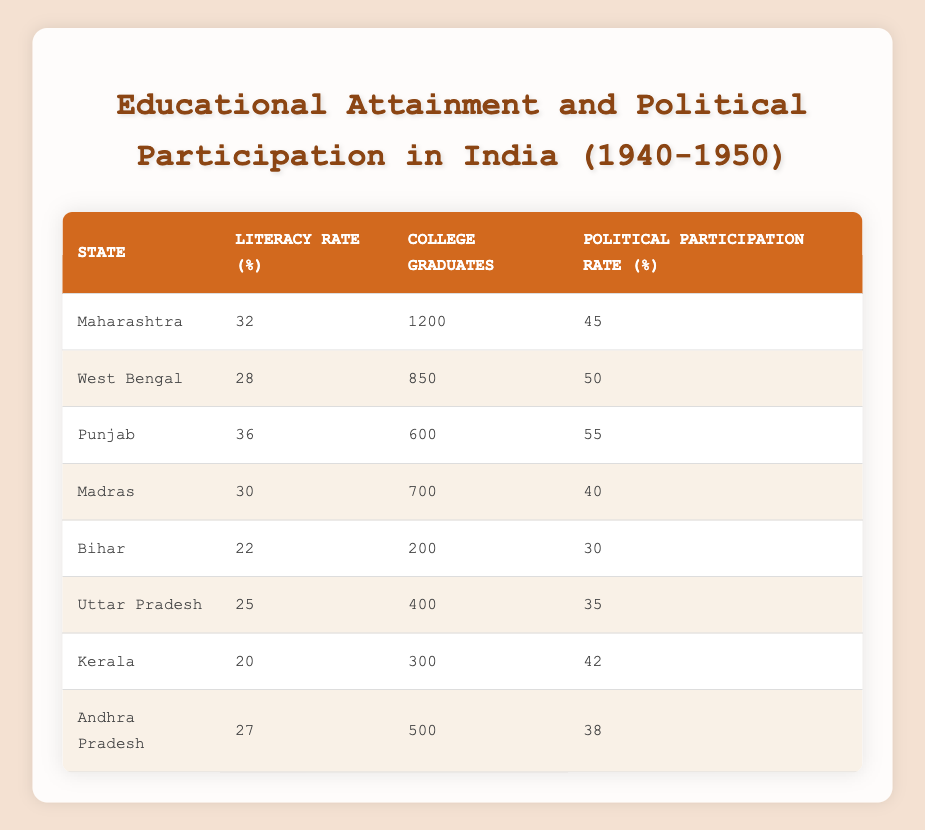What is the highest literacy rate among the states listed? By examining the "Literacy Rate (%)" column, I find that Punjab has the highest literacy rate at 36%.
Answer: 36% Which state has the lowest political participation rate? Looking at the "Political Participation Rate (%)" column, I see that Bihar has the lowest rate at 30%.
Answer: 30% Which state has the most college graduates? The "College Graduates" column shows that Maharashtra has the most college graduates, totaling 1200.
Answer: 1200 What is the average political participation rate across all states? Adding the political participation rates ((45 + 50 + 55 + 40 + 30 + 35 + 42 + 38) = 335) and dividing by the number of states (8) gives an average of 335 / 8 = 41.875, rounding to 42%.
Answer: 42% True or False: Kerala has a higher political participation rate compared to Uttar Pradesh. Comparing the political participation rates, Kerala is at 42% and Uttar Pradesh at 35%, so the statement is true.
Answer: True How many states have a literacy rate above 30%? I count the states with literacy rates over 30%: Maharashtra (32%), Punjab (36%), and Madras (30% is not over 30%), yielding a total of 2 states (Maharashtra and Punjab).
Answer: 2 What is the difference between the highest and lowest literacy rates? The highest literacy rate is 36% (Punjab) and the lowest is 22% (Bihar), so the difference is 36 - 22 = 14%.
Answer: 14% If the political participation rate increased by 10% in Bihar, what would the new rate be? Adding 10% to Bihar's current political participation rate of 30% gives 30 + 10 = 40%.
Answer: 40% Which two states have similar levels of college graduates, and what are those numbers? By looking at the "College Graduates" column, Andhra Pradesh (500) and Uttar Pradesh (400) are close in number, thus they are grouped; their numbers are 500 and 400, respectively.
Answer: 500 and 400 